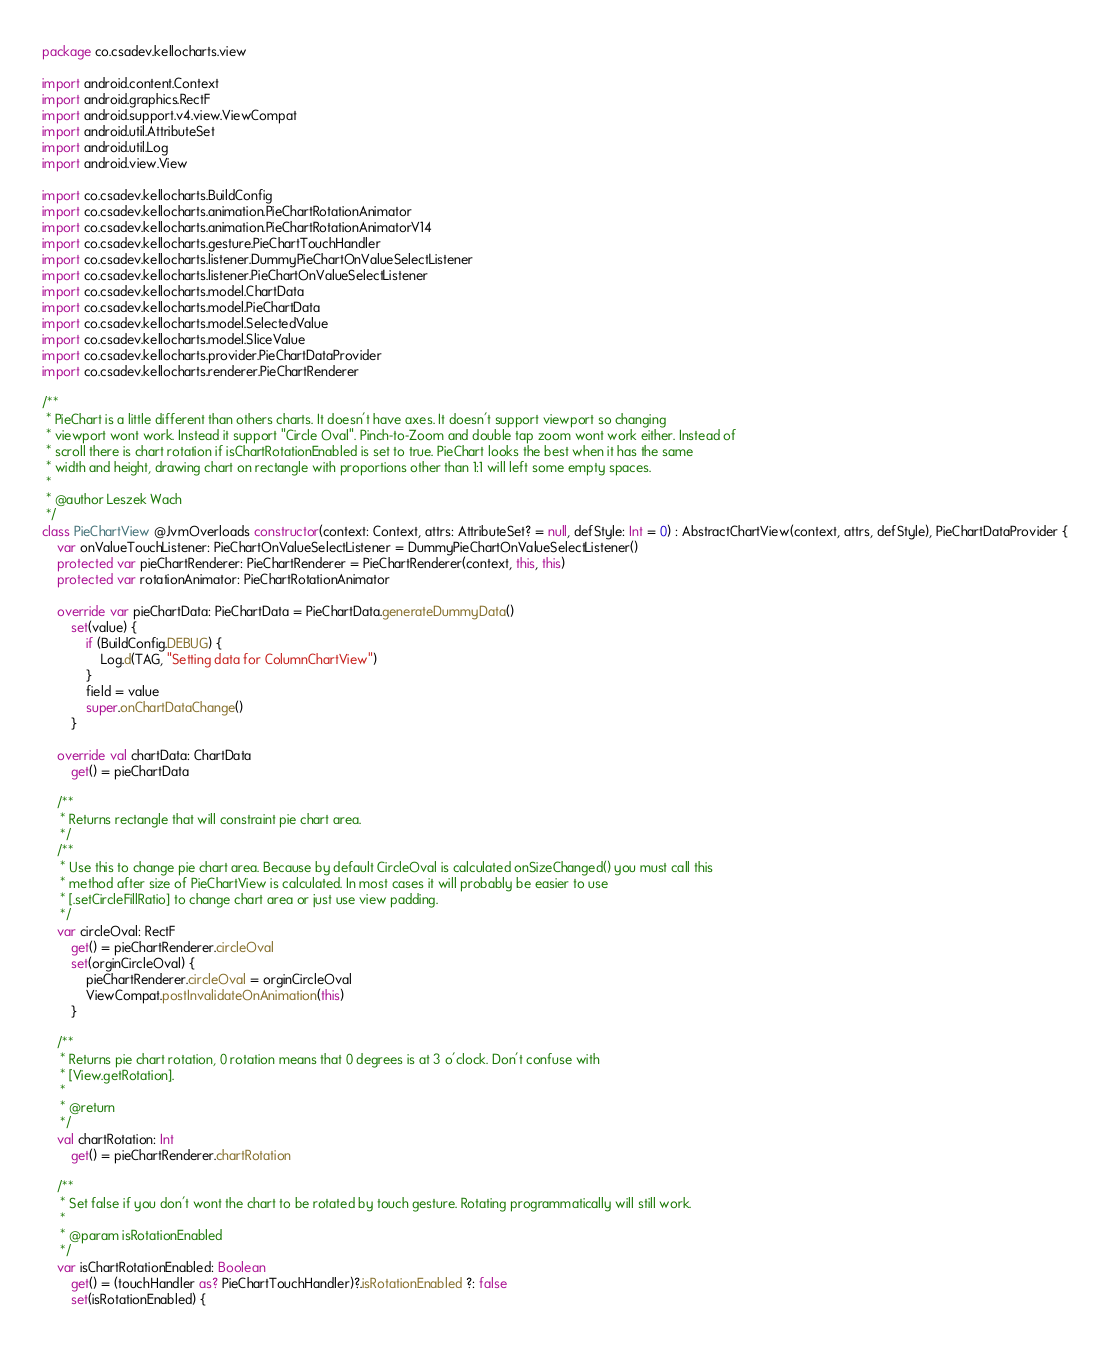<code> <loc_0><loc_0><loc_500><loc_500><_Kotlin_>package co.csadev.kellocharts.view

import android.content.Context
import android.graphics.RectF
import android.support.v4.view.ViewCompat
import android.util.AttributeSet
import android.util.Log
import android.view.View

import co.csadev.kellocharts.BuildConfig
import co.csadev.kellocharts.animation.PieChartRotationAnimator
import co.csadev.kellocharts.animation.PieChartRotationAnimatorV14
import co.csadev.kellocharts.gesture.PieChartTouchHandler
import co.csadev.kellocharts.listener.DummyPieChartOnValueSelectListener
import co.csadev.kellocharts.listener.PieChartOnValueSelectListener
import co.csadev.kellocharts.model.ChartData
import co.csadev.kellocharts.model.PieChartData
import co.csadev.kellocharts.model.SelectedValue
import co.csadev.kellocharts.model.SliceValue
import co.csadev.kellocharts.provider.PieChartDataProvider
import co.csadev.kellocharts.renderer.PieChartRenderer

/**
 * PieChart is a little different than others charts. It doesn't have axes. It doesn't support viewport so changing
 * viewport wont work. Instead it support "Circle Oval". Pinch-to-Zoom and double tap zoom wont work either. Instead of
 * scroll there is chart rotation if isChartRotationEnabled is set to true. PieChart looks the best when it has the same
 * width and height, drawing chart on rectangle with proportions other than 1:1 will left some empty spaces.
 *
 * @author Leszek Wach
 */
class PieChartView @JvmOverloads constructor(context: Context, attrs: AttributeSet? = null, defStyle: Int = 0) : AbstractChartView(context, attrs, defStyle), PieChartDataProvider {
    var onValueTouchListener: PieChartOnValueSelectListener = DummyPieChartOnValueSelectListener()
    protected var pieChartRenderer: PieChartRenderer = PieChartRenderer(context, this, this)
    protected var rotationAnimator: PieChartRotationAnimator

    override var pieChartData: PieChartData = PieChartData.generateDummyData()
        set(value) {
            if (BuildConfig.DEBUG) {
                Log.d(TAG, "Setting data for ColumnChartView")
            }
            field = value
            super.onChartDataChange()
        }

    override val chartData: ChartData
        get() = pieChartData

    /**
     * Returns rectangle that will constraint pie chart area.
     */
    /**
     * Use this to change pie chart area. Because by default CircleOval is calculated onSizeChanged() you must call this
     * method after size of PieChartView is calculated. In most cases it will probably be easier to use
     * [.setCircleFillRatio] to change chart area or just use view padding.
     */
    var circleOval: RectF
        get() = pieChartRenderer.circleOval
        set(orginCircleOval) {
            pieChartRenderer.circleOval = orginCircleOval
            ViewCompat.postInvalidateOnAnimation(this)
        }

    /**
     * Returns pie chart rotation, 0 rotation means that 0 degrees is at 3 o'clock. Don't confuse with
     * [View.getRotation].
     *
     * @return
     */
    val chartRotation: Int
        get() = pieChartRenderer.chartRotation

    /**
     * Set false if you don't wont the chart to be rotated by touch gesture. Rotating programmatically will still work.
     *
     * @param isRotationEnabled
     */
    var isChartRotationEnabled: Boolean
        get() = (touchHandler as? PieChartTouchHandler)?.isRotationEnabled ?: false
        set(isRotationEnabled) {</code> 